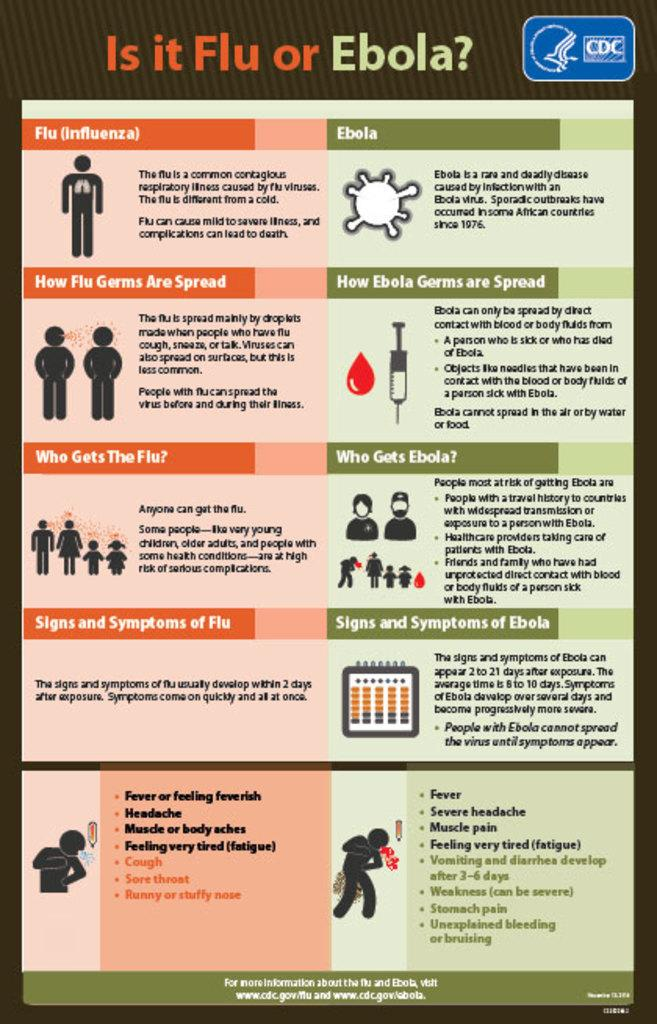<image>
Provide a brief description of the given image. a CDC brochure about is it flu or ebola 